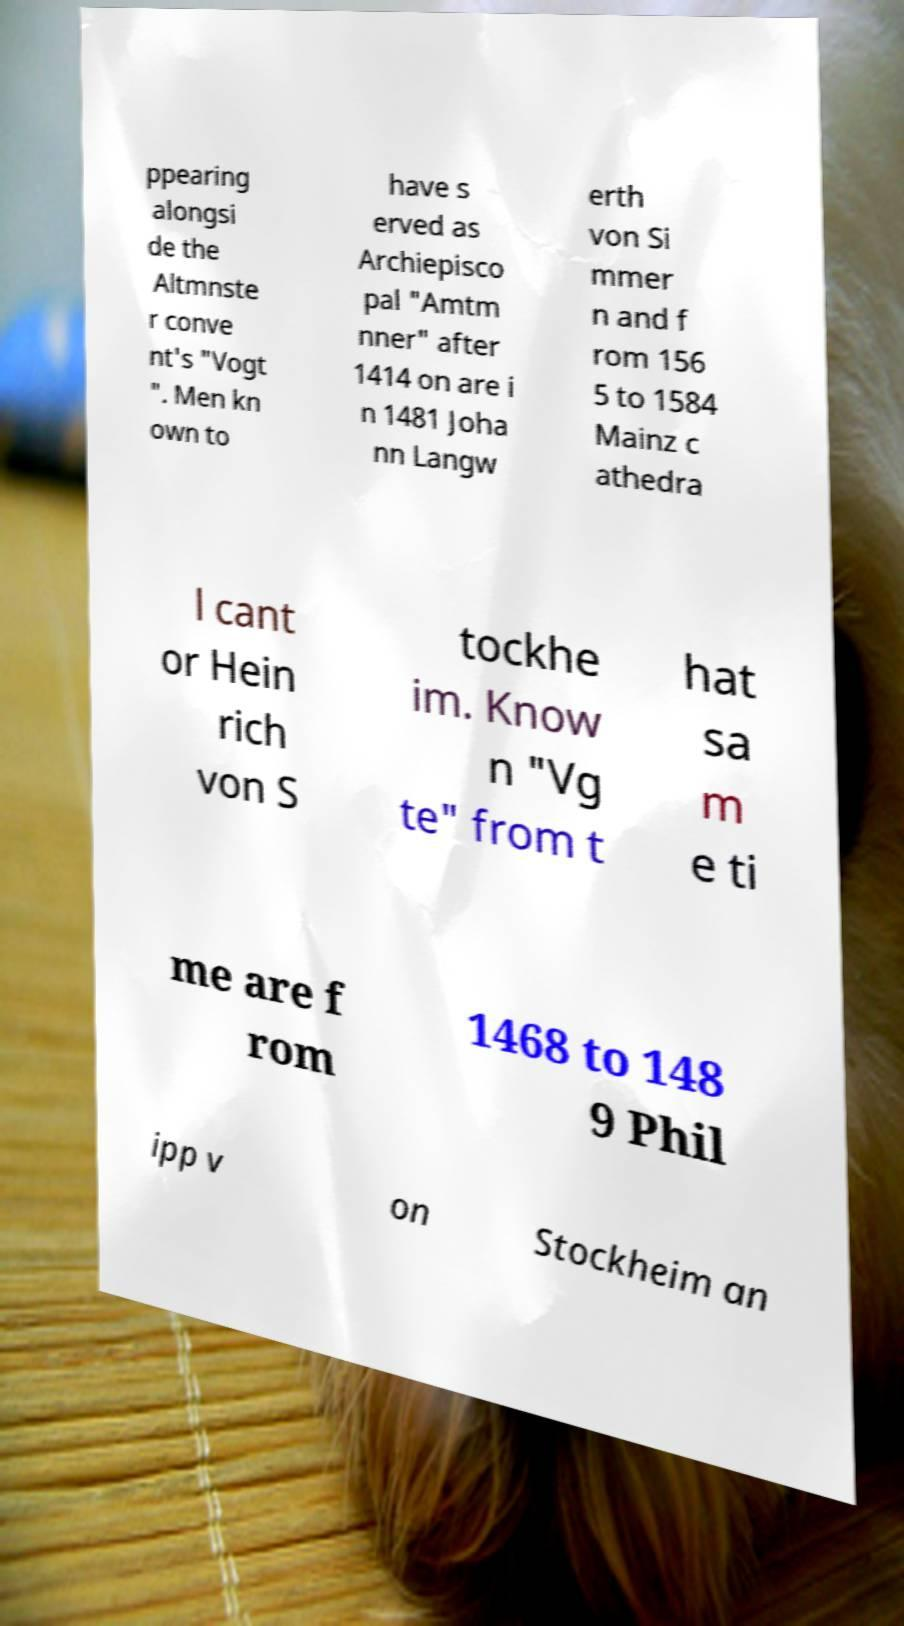Can you accurately transcribe the text from the provided image for me? ppearing alongsi de the Altmnste r conve nt's "Vogt ". Men kn own to have s erved as Archiepisco pal "Amtm nner" after 1414 on are i n 1481 Joha nn Langw erth von Si mmer n and f rom 156 5 to 1584 Mainz c athedra l cant or Hein rich von S tockhe im. Know n "Vg te" from t hat sa m e ti me are f rom 1468 to 148 9 Phil ipp v on Stockheim an 